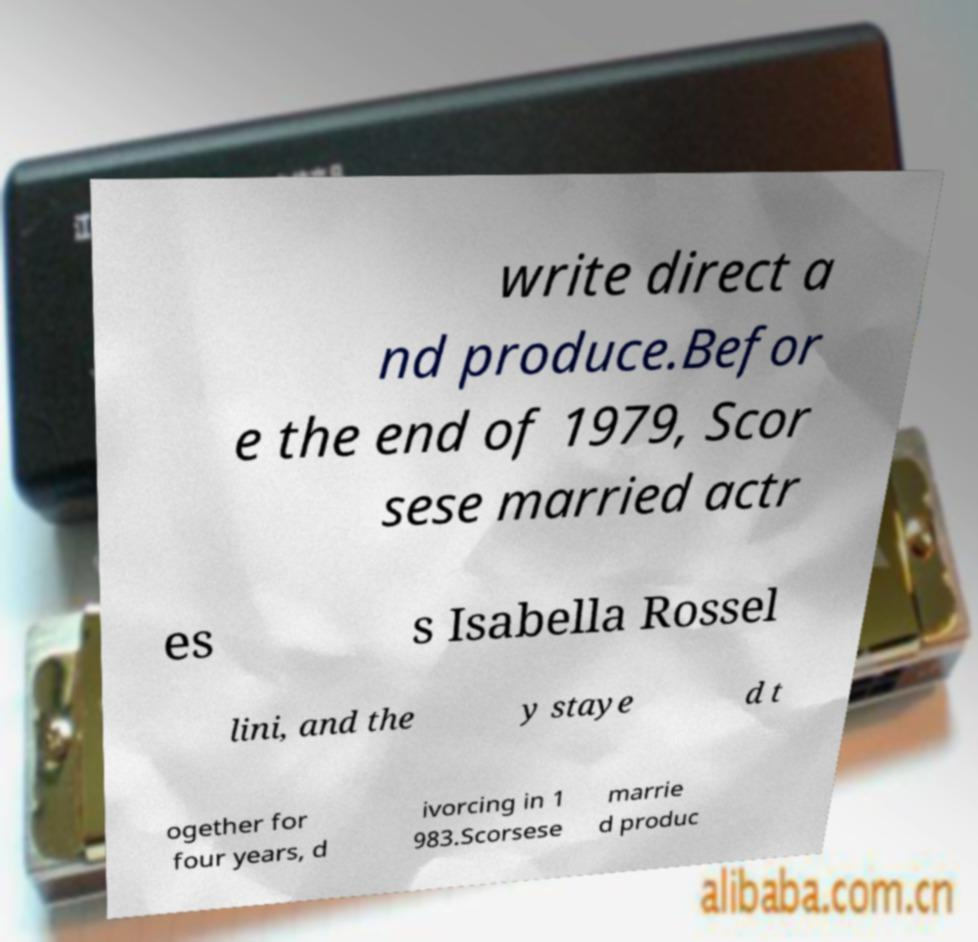Can you read and provide the text displayed in the image?This photo seems to have some interesting text. Can you extract and type it out for me? write direct a nd produce.Befor e the end of 1979, Scor sese married actr es s Isabella Rossel lini, and the y staye d t ogether for four years, d ivorcing in 1 983.Scorsese marrie d produc 